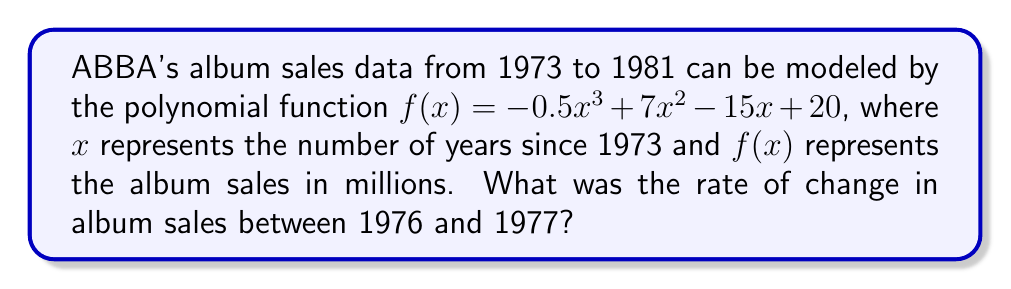What is the answer to this math problem? To find the rate of change between 1976 and 1977, we need to:

1. Calculate the derivative of the given function:
   $f'(x) = -1.5x^2 + 14x - 15$

2. Find the values of x for 1976 and 1977:
   1976 is 3 years after 1973, so $x_1 = 3$
   1977 is 4 years after 1973, so $x_2 = 4$

3. Calculate the average rate of change:
   Average rate of change = $\frac{f'(x_1) + f'(x_2)}{2}$

4. Evaluate $f'(3)$:
   $f'(3) = -1.5(3)^2 + 14(3) - 15 = -13.5 + 42 - 15 = 13.5$

5. Evaluate $f'(4)$:
   $f'(4) = -1.5(4)^2 + 14(4) - 15 = -24 + 56 - 15 = 17$

6. Calculate the average:
   Average rate of change = $\frac{13.5 + 17}{2} = \frac{30.5}{2} = 15.25$

Therefore, the rate of change in album sales between 1976 and 1977 was 15.25 million albums per year.
Answer: 15.25 million albums/year 